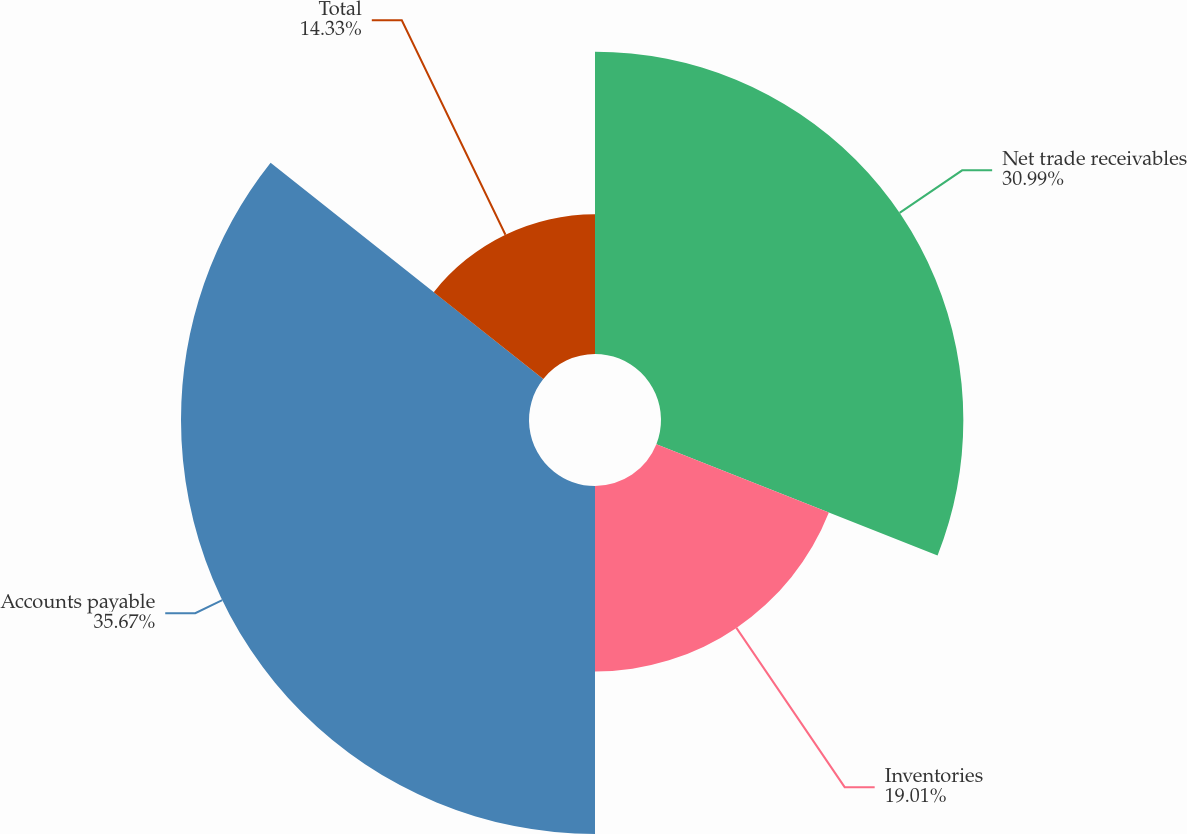<chart> <loc_0><loc_0><loc_500><loc_500><pie_chart><fcel>Net trade receivables<fcel>Inventories<fcel>Accounts payable<fcel>Total<nl><fcel>30.99%<fcel>19.01%<fcel>35.67%<fcel>14.33%<nl></chart> 